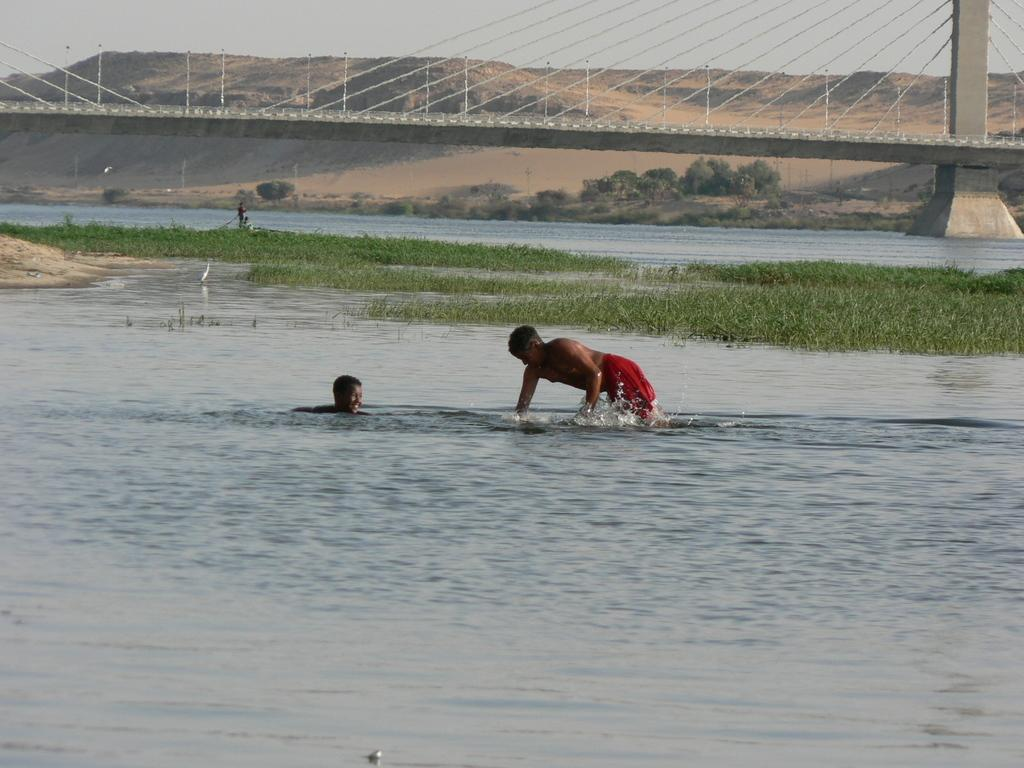What are the two boys in the image doing? The two boys are swimming in the water. What can be seen in the background of the image? There is grass and a bridge in the background of the image. What is located behind the bridge? There are hills behind the bridge. What type of cap is the fly wearing in the image? There is no fly or cap present in the image. What type of vacation are the boys on in the image? The image does not provide any information about the boys' vacation or their location. 